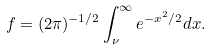Convert formula to latex. <formula><loc_0><loc_0><loc_500><loc_500>f = ( 2 \pi ) ^ { - 1 / 2 } \int _ { \nu } ^ { \infty } e ^ { - x ^ { 2 } / 2 } d x .</formula> 